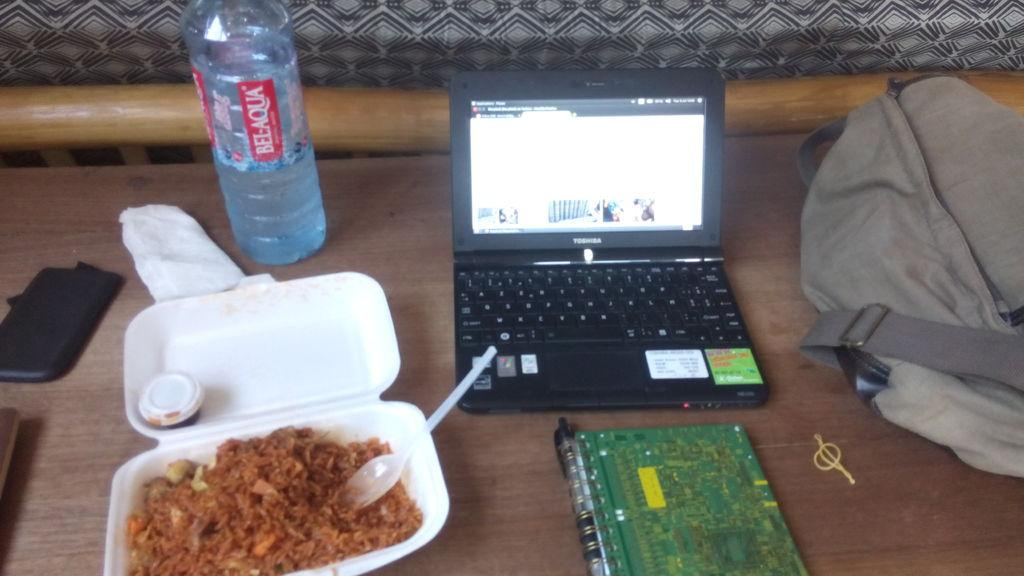<image>
Offer a succinct explanation of the picture presented. A bottle of Bel-Aqua is placed above a container of food. 